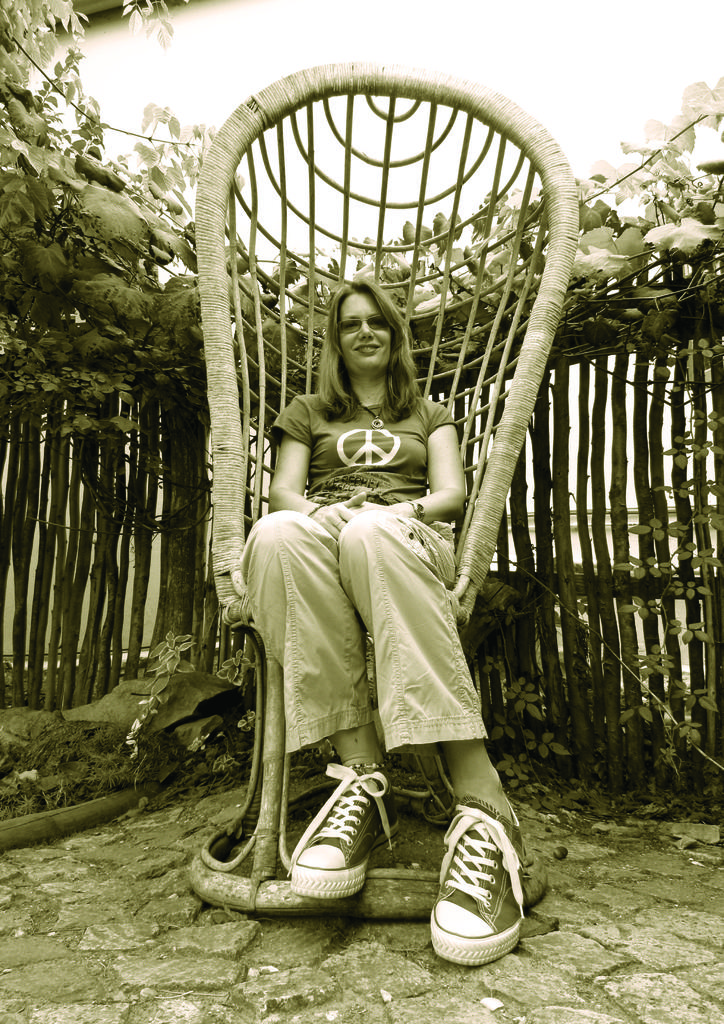Who is the main subject in the image? There is a girl in the image. What is the girl doing in the image? The girl is sitting on a chair. What can be seen in the background of the image? There are trees around the area of the image. What accessories is the girl wearing in the image? The girl is wearing sunglasses and shoes. What type of caption is written on the girl's shirt in the image? There is no caption written on the girl's shirt in the image. What game is the girl playing in the image? There is no game being played in the image; the girl is simply sitting on a chair. 